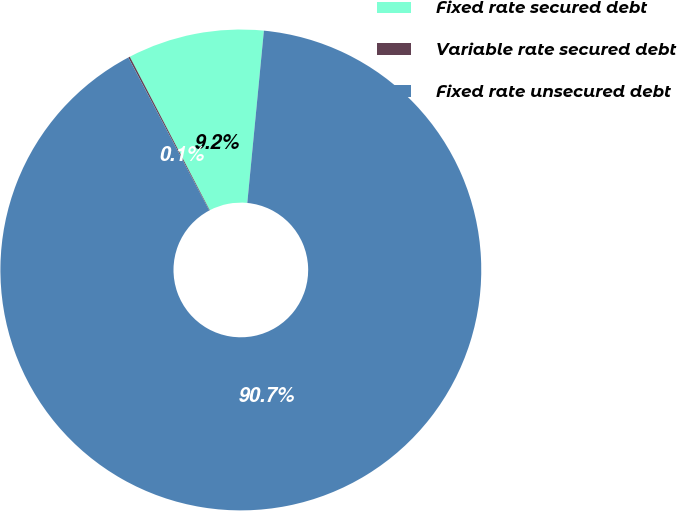Convert chart to OTSL. <chart><loc_0><loc_0><loc_500><loc_500><pie_chart><fcel>Fixed rate secured debt<fcel>Variable rate secured debt<fcel>Fixed rate unsecured debt<nl><fcel>9.17%<fcel>0.11%<fcel>90.72%<nl></chart> 